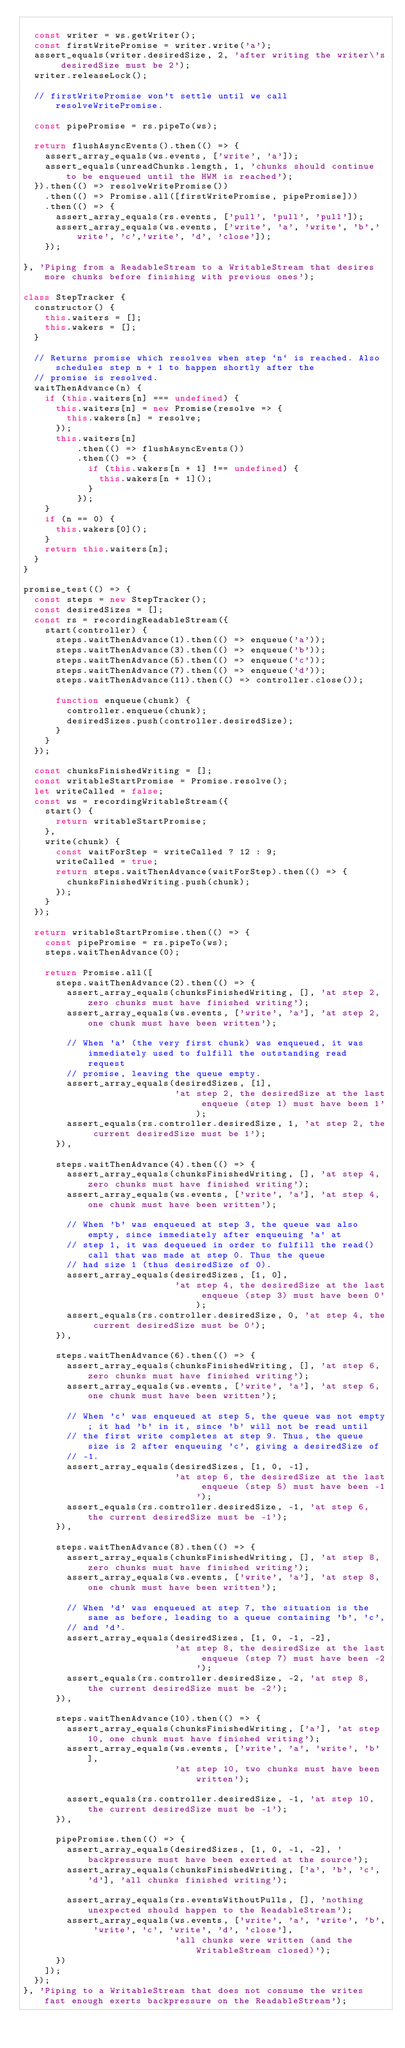<code> <loc_0><loc_0><loc_500><loc_500><_JavaScript_>
  const writer = ws.getWriter();
  const firstWritePromise = writer.write('a');
  assert_equals(writer.desiredSize, 2, 'after writing the writer\'s desiredSize must be 2');
  writer.releaseLock();

  // firstWritePromise won't settle until we call resolveWritePromise.

  const pipePromise = rs.pipeTo(ws);

  return flushAsyncEvents().then(() => {
    assert_array_equals(ws.events, ['write', 'a']);
    assert_equals(unreadChunks.length, 1, 'chunks should continue to be enqueued until the HWM is reached');
  }).then(() => resolveWritePromise())
    .then(() => Promise.all([firstWritePromise, pipePromise]))
    .then(() => {
      assert_array_equals(rs.events, ['pull', 'pull', 'pull']);
      assert_array_equals(ws.events, ['write', 'a', 'write', 'b','write', 'c','write', 'd', 'close']);
    });

}, 'Piping from a ReadableStream to a WritableStream that desires more chunks before finishing with previous ones');

class StepTracker {
  constructor() {
    this.waiters = [];
    this.wakers = [];
  }

  // Returns promise which resolves when step `n` is reached. Also schedules step n + 1 to happen shortly after the
  // promise is resolved.
  waitThenAdvance(n) {
    if (this.waiters[n] === undefined) {
      this.waiters[n] = new Promise(resolve => {
        this.wakers[n] = resolve;
      });
      this.waiters[n]
          .then(() => flushAsyncEvents())
          .then(() => {
            if (this.wakers[n + 1] !== undefined) {
              this.wakers[n + 1]();
            }
          });
    }
    if (n == 0) {
      this.wakers[0]();
    }
    return this.waiters[n];
  }
}

promise_test(() => {
  const steps = new StepTracker();
  const desiredSizes = [];
  const rs = recordingReadableStream({
    start(controller) {
      steps.waitThenAdvance(1).then(() => enqueue('a'));
      steps.waitThenAdvance(3).then(() => enqueue('b'));
      steps.waitThenAdvance(5).then(() => enqueue('c'));
      steps.waitThenAdvance(7).then(() => enqueue('d'));
      steps.waitThenAdvance(11).then(() => controller.close());

      function enqueue(chunk) {
        controller.enqueue(chunk);
        desiredSizes.push(controller.desiredSize);
      }
    }
  });

  const chunksFinishedWriting = [];
  const writableStartPromise = Promise.resolve();
  let writeCalled = false;
  const ws = recordingWritableStream({
    start() {
      return writableStartPromise;
    },
    write(chunk) {
      const waitForStep = writeCalled ? 12 : 9;
      writeCalled = true;
      return steps.waitThenAdvance(waitForStep).then(() => {
        chunksFinishedWriting.push(chunk);
      });
    }
  });

  return writableStartPromise.then(() => {
    const pipePromise = rs.pipeTo(ws);
    steps.waitThenAdvance(0);

    return Promise.all([
      steps.waitThenAdvance(2).then(() => {
        assert_array_equals(chunksFinishedWriting, [], 'at step 2, zero chunks must have finished writing');
        assert_array_equals(ws.events, ['write', 'a'], 'at step 2, one chunk must have been written');

        // When 'a' (the very first chunk) was enqueued, it was immediately used to fulfill the outstanding read request
        // promise, leaving the queue empty.
        assert_array_equals(desiredSizes, [1],
                            'at step 2, the desiredSize at the last enqueue (step 1) must have been 1');
        assert_equals(rs.controller.desiredSize, 1, 'at step 2, the current desiredSize must be 1');
      }),

      steps.waitThenAdvance(4).then(() => {
        assert_array_equals(chunksFinishedWriting, [], 'at step 4, zero chunks must have finished writing');
        assert_array_equals(ws.events, ['write', 'a'], 'at step 4, one chunk must have been written');

        // When 'b' was enqueued at step 3, the queue was also empty, since immediately after enqueuing 'a' at
        // step 1, it was dequeued in order to fulfill the read() call that was made at step 0. Thus the queue
        // had size 1 (thus desiredSize of 0).
        assert_array_equals(desiredSizes, [1, 0],
                            'at step 4, the desiredSize at the last enqueue (step 3) must have been 0');
        assert_equals(rs.controller.desiredSize, 0, 'at step 4, the current desiredSize must be 0');
      }),

      steps.waitThenAdvance(6).then(() => {
        assert_array_equals(chunksFinishedWriting, [], 'at step 6, zero chunks must have finished writing');
        assert_array_equals(ws.events, ['write', 'a'], 'at step 6, one chunk must have been written');

        // When 'c' was enqueued at step 5, the queue was not empty; it had 'b' in it, since 'b' will not be read until
        // the first write completes at step 9. Thus, the queue size is 2 after enqueuing 'c', giving a desiredSize of
        // -1.
        assert_array_equals(desiredSizes, [1, 0, -1],
                            'at step 6, the desiredSize at the last enqueue (step 5) must have been -1');
        assert_equals(rs.controller.desiredSize, -1, 'at step 6, the current desiredSize must be -1');
      }),

      steps.waitThenAdvance(8).then(() => {
        assert_array_equals(chunksFinishedWriting, [], 'at step 8, zero chunks must have finished writing');
        assert_array_equals(ws.events, ['write', 'a'], 'at step 8, one chunk must have been written');

        // When 'd' was enqueued at step 7, the situation is the same as before, leading to a queue containing 'b', 'c',
        // and 'd'.
        assert_array_equals(desiredSizes, [1, 0, -1, -2],
                            'at step 8, the desiredSize at the last enqueue (step 7) must have been -2');
        assert_equals(rs.controller.desiredSize, -2, 'at step 8, the current desiredSize must be -2');
      }),

      steps.waitThenAdvance(10).then(() => {
        assert_array_equals(chunksFinishedWriting, ['a'], 'at step 10, one chunk must have finished writing');
        assert_array_equals(ws.events, ['write', 'a', 'write', 'b'],
                            'at step 10, two chunks must have been written');

        assert_equals(rs.controller.desiredSize, -1, 'at step 10, the current desiredSize must be -1');
      }),

      pipePromise.then(() => {
        assert_array_equals(desiredSizes, [1, 0, -1, -2], 'backpressure must have been exerted at the source');
        assert_array_equals(chunksFinishedWriting, ['a', 'b', 'c', 'd'], 'all chunks finished writing');

        assert_array_equals(rs.eventsWithoutPulls, [], 'nothing unexpected should happen to the ReadableStream');
        assert_array_equals(ws.events, ['write', 'a', 'write', 'b', 'write', 'c', 'write', 'd', 'close'],
                            'all chunks were written (and the WritableStream closed)');
      })
    ]);
  });
}, 'Piping to a WritableStream that does not consume the writes fast enough exerts backpressure on the ReadableStream');
</code> 